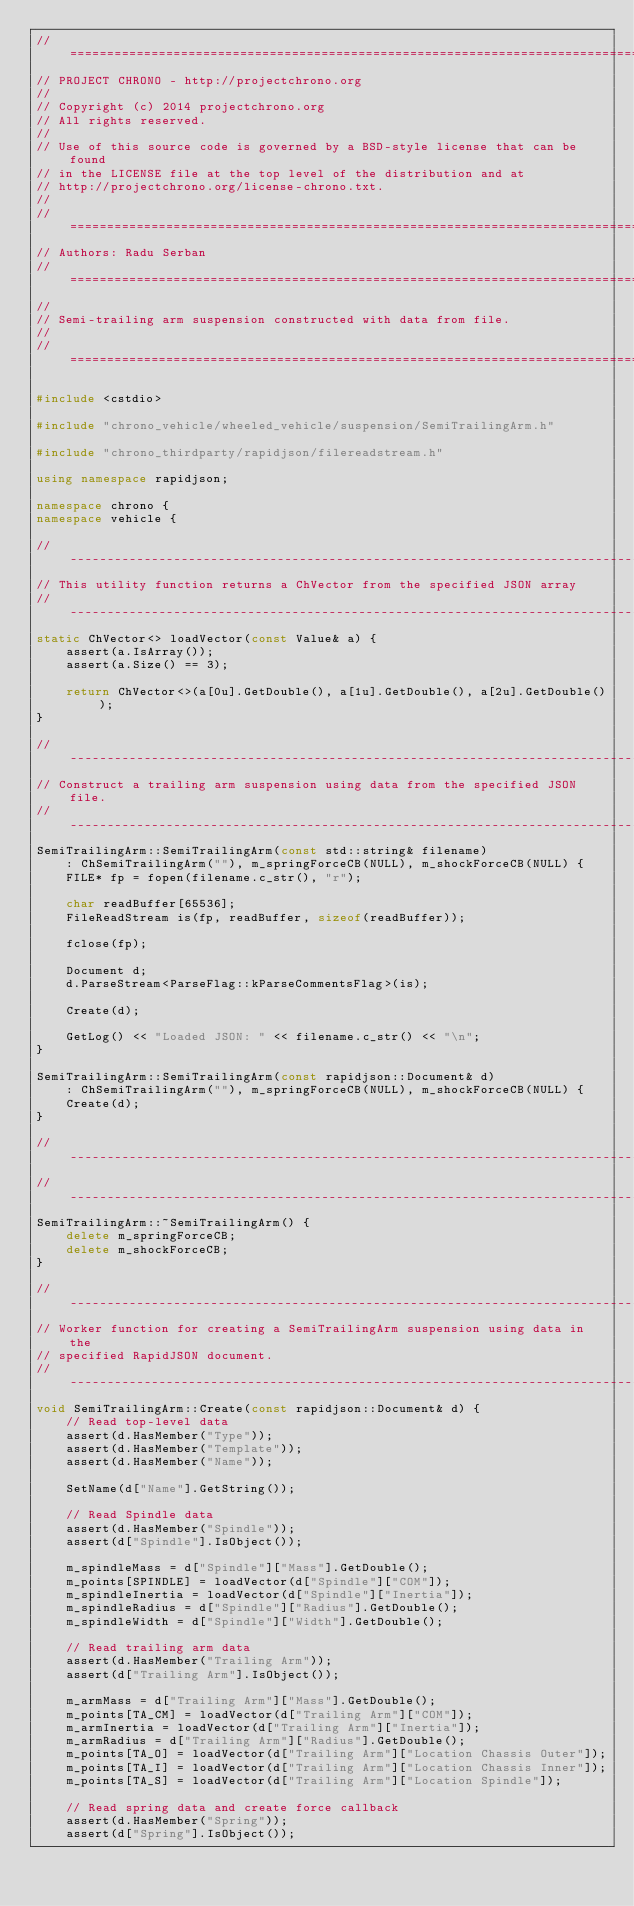<code> <loc_0><loc_0><loc_500><loc_500><_C++_>// =============================================================================
// PROJECT CHRONO - http://projectchrono.org
//
// Copyright (c) 2014 projectchrono.org
// All rights reserved.
//
// Use of this source code is governed by a BSD-style license that can be found
// in the LICENSE file at the top level of the distribution and at
// http://projectchrono.org/license-chrono.txt.
//
// =============================================================================
// Authors: Radu Serban
// =============================================================================
//
// Semi-trailing arm suspension constructed with data from file.
//
// =============================================================================

#include <cstdio>

#include "chrono_vehicle/wheeled_vehicle/suspension/SemiTrailingArm.h"

#include "chrono_thirdparty/rapidjson/filereadstream.h"

using namespace rapidjson;

namespace chrono {
namespace vehicle {

// -----------------------------------------------------------------------------
// This utility function returns a ChVector from the specified JSON array
// -----------------------------------------------------------------------------
static ChVector<> loadVector(const Value& a) {
    assert(a.IsArray());
    assert(a.Size() == 3);

    return ChVector<>(a[0u].GetDouble(), a[1u].GetDouble(), a[2u].GetDouble());
}

// -----------------------------------------------------------------------------
// Construct a trailing arm suspension using data from the specified JSON file.
// -----------------------------------------------------------------------------
SemiTrailingArm::SemiTrailingArm(const std::string& filename)
    : ChSemiTrailingArm(""), m_springForceCB(NULL), m_shockForceCB(NULL) {
    FILE* fp = fopen(filename.c_str(), "r");

    char readBuffer[65536];
    FileReadStream is(fp, readBuffer, sizeof(readBuffer));

    fclose(fp);

    Document d;
    d.ParseStream<ParseFlag::kParseCommentsFlag>(is);

    Create(d);

    GetLog() << "Loaded JSON: " << filename.c_str() << "\n";
}

SemiTrailingArm::SemiTrailingArm(const rapidjson::Document& d)
    : ChSemiTrailingArm(""), m_springForceCB(NULL), m_shockForceCB(NULL) {
    Create(d);
}

// -----------------------------------------------------------------------------
// -----------------------------------------------------------------------------
SemiTrailingArm::~SemiTrailingArm() {
    delete m_springForceCB;
    delete m_shockForceCB;
}

// -----------------------------------------------------------------------------
// Worker function for creating a SemiTrailingArm suspension using data in the
// specified RapidJSON document.
// -----------------------------------------------------------------------------
void SemiTrailingArm::Create(const rapidjson::Document& d) {
    // Read top-level data
    assert(d.HasMember("Type"));
    assert(d.HasMember("Template"));
    assert(d.HasMember("Name"));

    SetName(d["Name"].GetString());

    // Read Spindle data
    assert(d.HasMember("Spindle"));
    assert(d["Spindle"].IsObject());

    m_spindleMass = d["Spindle"]["Mass"].GetDouble();
    m_points[SPINDLE] = loadVector(d["Spindle"]["COM"]);
    m_spindleInertia = loadVector(d["Spindle"]["Inertia"]);
    m_spindleRadius = d["Spindle"]["Radius"].GetDouble();
    m_spindleWidth = d["Spindle"]["Width"].GetDouble();

    // Read trailing arm data
    assert(d.HasMember("Trailing Arm"));
    assert(d["Trailing Arm"].IsObject());

    m_armMass = d["Trailing Arm"]["Mass"].GetDouble();
    m_points[TA_CM] = loadVector(d["Trailing Arm"]["COM"]);
    m_armInertia = loadVector(d["Trailing Arm"]["Inertia"]);
    m_armRadius = d["Trailing Arm"]["Radius"].GetDouble();
    m_points[TA_O] = loadVector(d["Trailing Arm"]["Location Chassis Outer"]);
    m_points[TA_I] = loadVector(d["Trailing Arm"]["Location Chassis Inner"]);
    m_points[TA_S] = loadVector(d["Trailing Arm"]["Location Spindle"]);

    // Read spring data and create force callback
    assert(d.HasMember("Spring"));
    assert(d["Spring"].IsObject());
</code> 